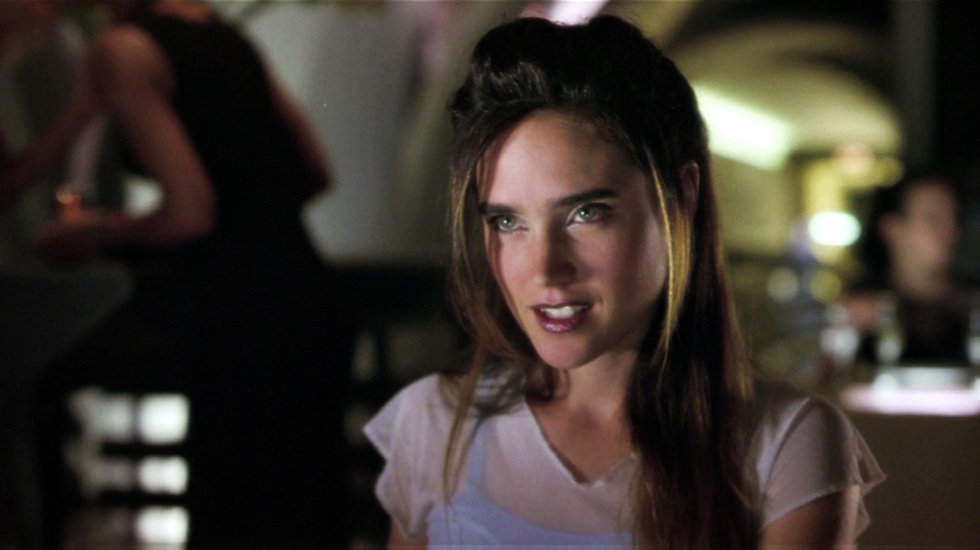What kind of atmosphere does this image convey? The atmosphere in the image seems relaxed and intimate, indicated by the subdued lighting and the softness of the background. The setting looks like a bar or lounge, where the ambient light often creates a cozy and inviting space. This, combined with the woman's content expression, imparts a sense of casual serenity. 